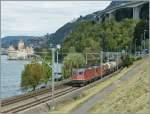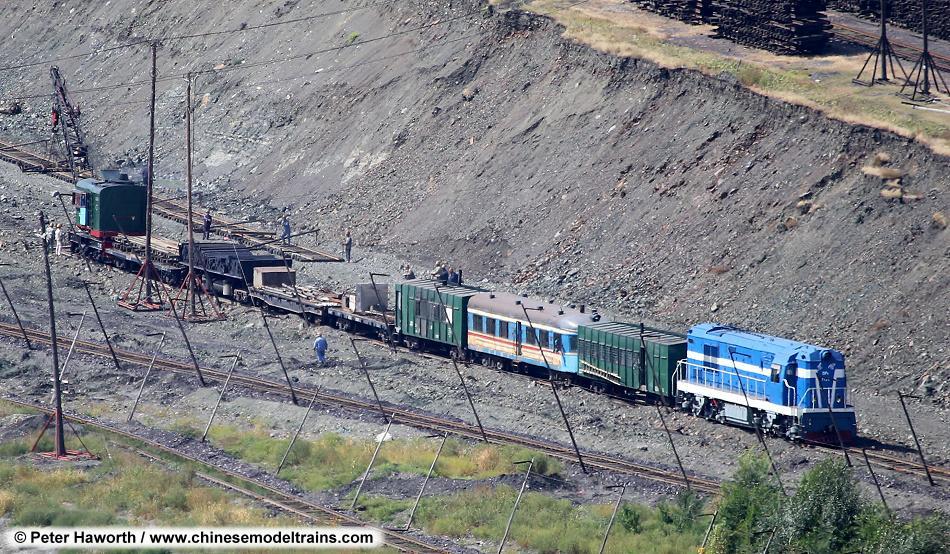The first image is the image on the left, the second image is the image on the right. For the images displayed, is the sentence "The front car of the train in the right image has a red tint to it." factually correct? Answer yes or no. No. The first image is the image on the left, the second image is the image on the right. Analyze the images presented: Is the assertion "there are two sets of trains in the right side image" valid? Answer yes or no. No. 